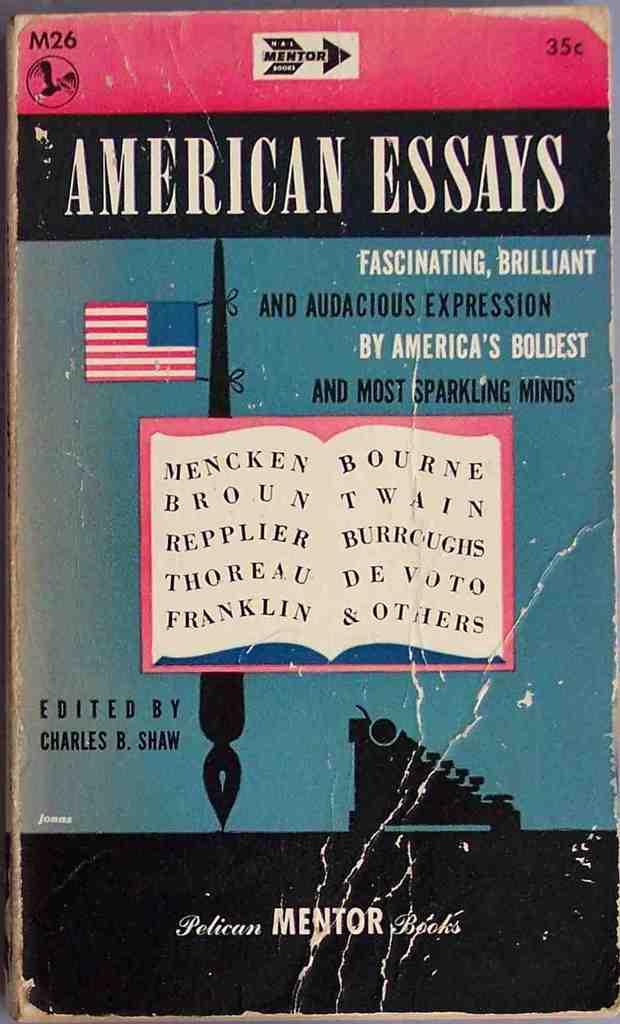<image>
Share a concise interpretation of the image provided. A work and creased book cover for American Essays. 